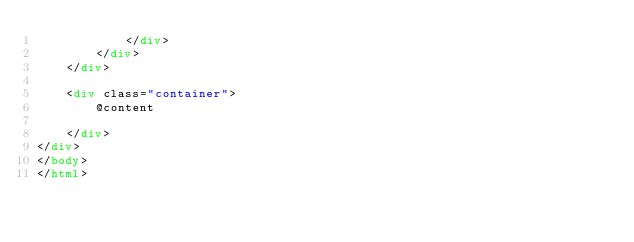Convert code to text. <code><loc_0><loc_0><loc_500><loc_500><_HTML_>            </div>
        </div>
    </div>

    <div class="container">
        @content

    </div>
</div>
</body>
</html>
</code> 